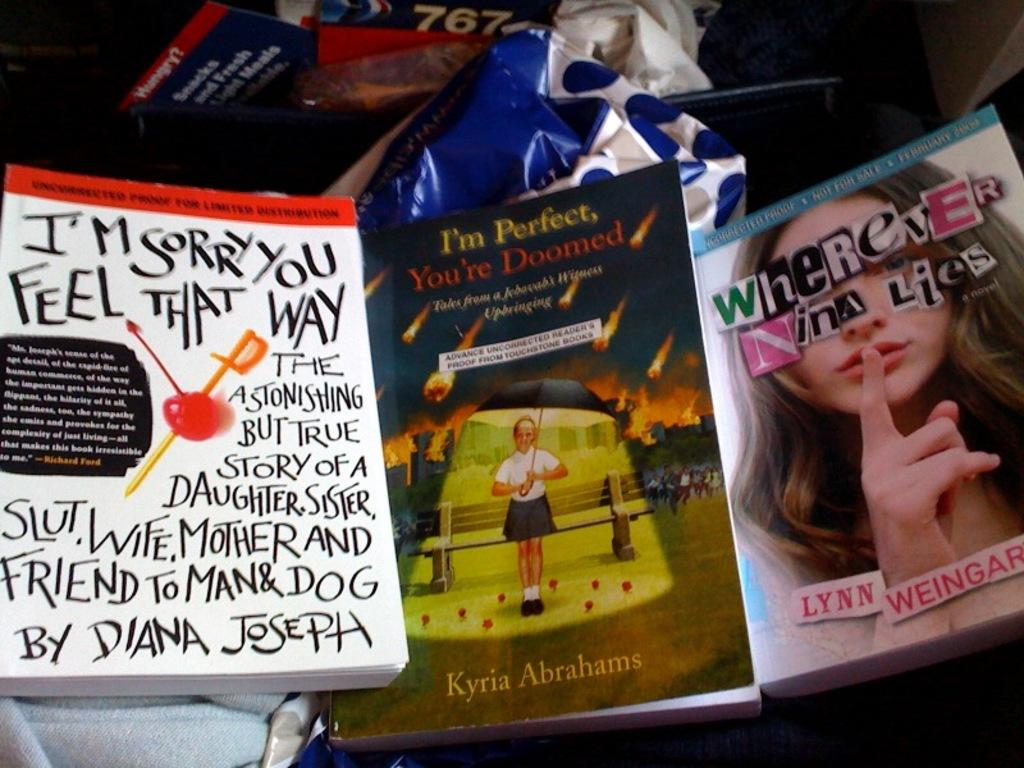What type of items can be seen in the image? There are books, objects, and clothes in the image. Can you describe the books in the image? The books have text, numerical numbers, and pictures on them. How many matches are visible in the image? There are no matches present in the image. What type of suit is being worn by the person in the image? There is no person visible in the image, so it is not possible to determine what type of suit they might be wearing. 